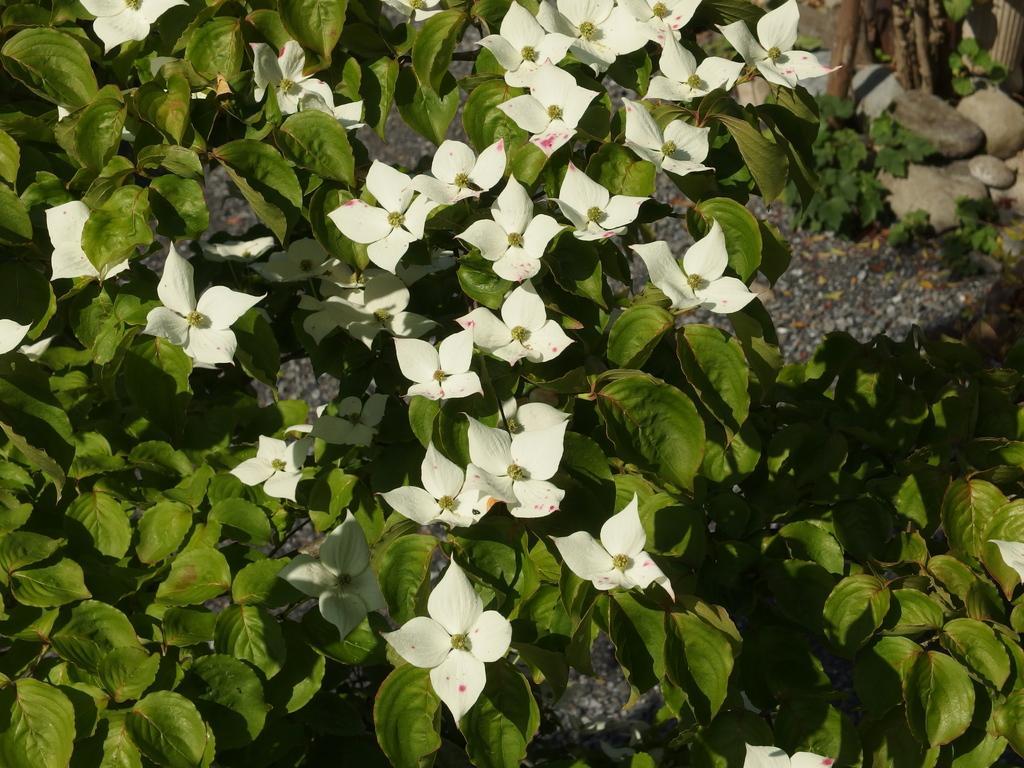How would you summarize this image in a sentence or two? There are plants having white color flowers and green color leaves. In the background, there are stones on the ground. 